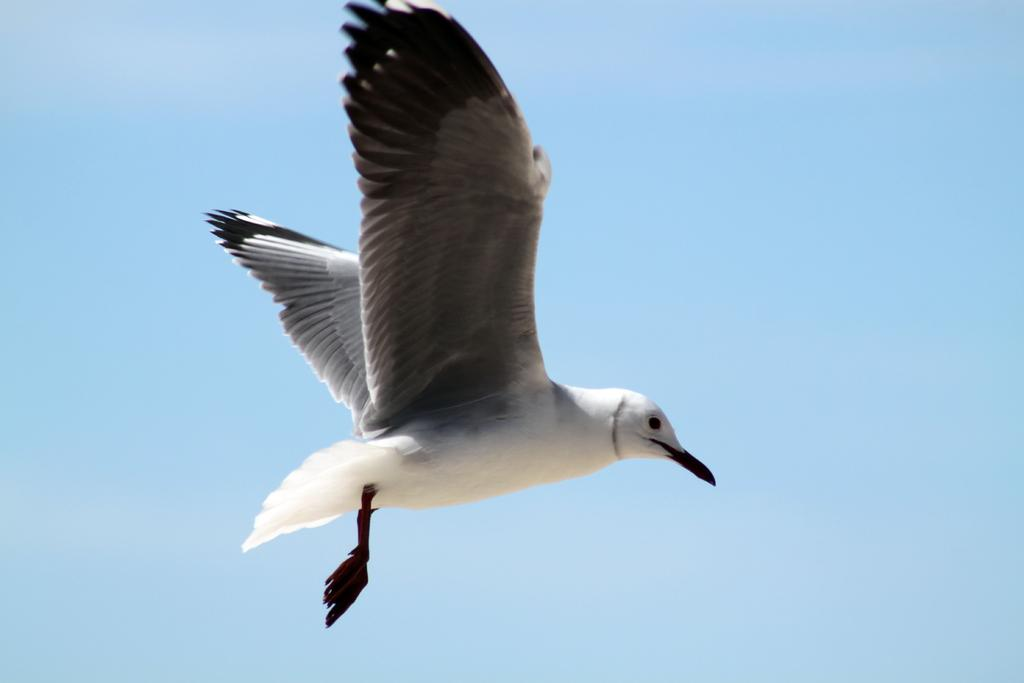What type of animal can be seen in the image? There is a bird in the image. What is the bird doing in the image? The bird is flying. What can be seen in the background of the image? The sky is visible in the background of the image. What type of beetle can be seen writing a letter in the image? There is no beetle or writing present in the image; it features a bird flying in the sky. 